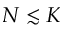<formula> <loc_0><loc_0><loc_500><loc_500>N \lesssim K</formula> 